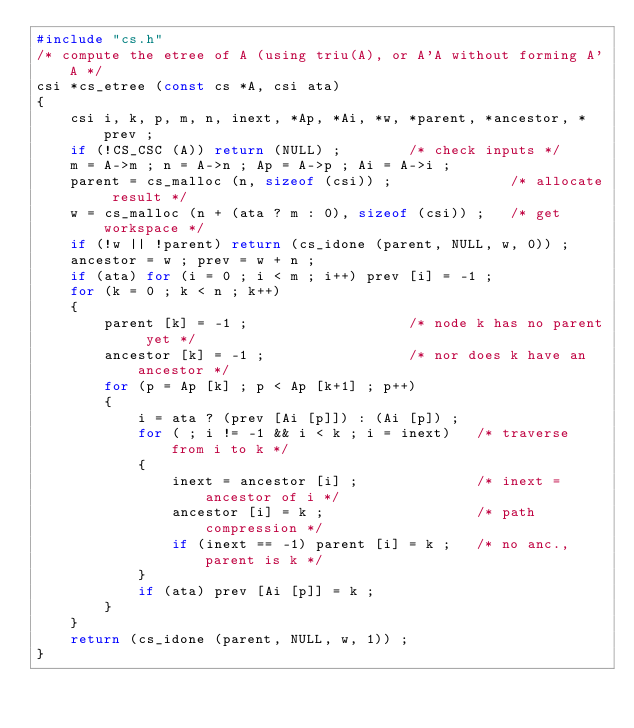Convert code to text. <code><loc_0><loc_0><loc_500><loc_500><_C_>#include "cs.h"
/* compute the etree of A (using triu(A), or A'A without forming A'A */
csi *cs_etree (const cs *A, csi ata)
{
    csi i, k, p, m, n, inext, *Ap, *Ai, *w, *parent, *ancestor, *prev ;
    if (!CS_CSC (A)) return (NULL) ;        /* check inputs */
    m = A->m ; n = A->n ; Ap = A->p ; Ai = A->i ;
    parent = cs_malloc (n, sizeof (csi)) ;              /* allocate result */
    w = cs_malloc (n + (ata ? m : 0), sizeof (csi)) ;   /* get workspace */
    if (!w || !parent) return (cs_idone (parent, NULL, w, 0)) ;
    ancestor = w ; prev = w + n ;
    if (ata) for (i = 0 ; i < m ; i++) prev [i] = -1 ;
    for (k = 0 ; k < n ; k++)
    {
        parent [k] = -1 ;                   /* node k has no parent yet */
        ancestor [k] = -1 ;                 /* nor does k have an ancestor */
        for (p = Ap [k] ; p < Ap [k+1] ; p++)
        {
            i = ata ? (prev [Ai [p]]) : (Ai [p]) ;
            for ( ; i != -1 && i < k ; i = inext)   /* traverse from i to k */
            {
                inext = ancestor [i] ;              /* inext = ancestor of i */
                ancestor [i] = k ;                  /* path compression */
                if (inext == -1) parent [i] = k ;   /* no anc., parent is k */
            }
            if (ata) prev [Ai [p]] = k ;
        }
    }
    return (cs_idone (parent, NULL, w, 1)) ;
}
</code> 